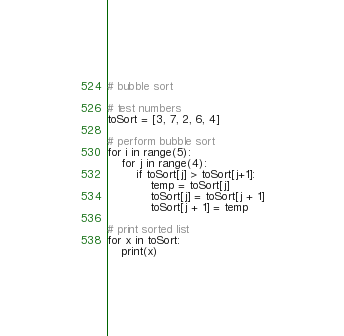<code> <loc_0><loc_0><loc_500><loc_500><_Python_># bubble sort

# test numbers
toSort = [3, 7, 2, 6, 4]

# perform bubble sort
for i in range(5):
    for j in range(4):
        if toSort[j] > toSort[j+1]:
            temp = toSort[j]
            toSort[j] = toSort[j + 1]
            toSort[j + 1] = temp

# print sorted list
for x in toSort:
    print(x)
</code> 